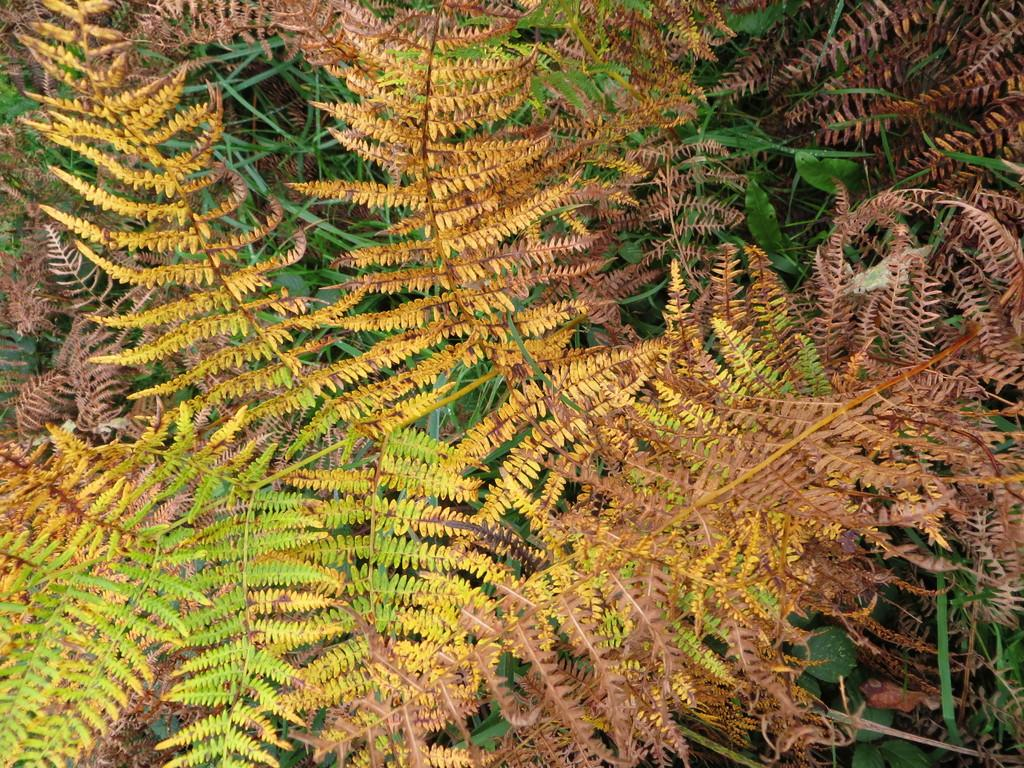What type of vegetation can be seen in the image? There are trees in the image. What are the main features of the trees? The trees have stems and leaves. Reasoning: Leting: Let's think step by step in order to produce the conversation. We start by identifying the main subject in the image, which is the trees. Then, we expand the conversation to include the specific features of the trees, such as their stems and leaves. Each question is designed to elicit a specific detail about the image that is known from the provided facts. Absurd Question/Answer: Are there any cherries growing on the trees in the image? There is no mention of cherries in the provided facts, so we cannot determine if they are present in the image. Is there any sense of shame associated with the trees in the image? There is no mention of emotions or feelings in the provided facts, so we cannot determine if there is any sense of shame associated with the trees in the image. 